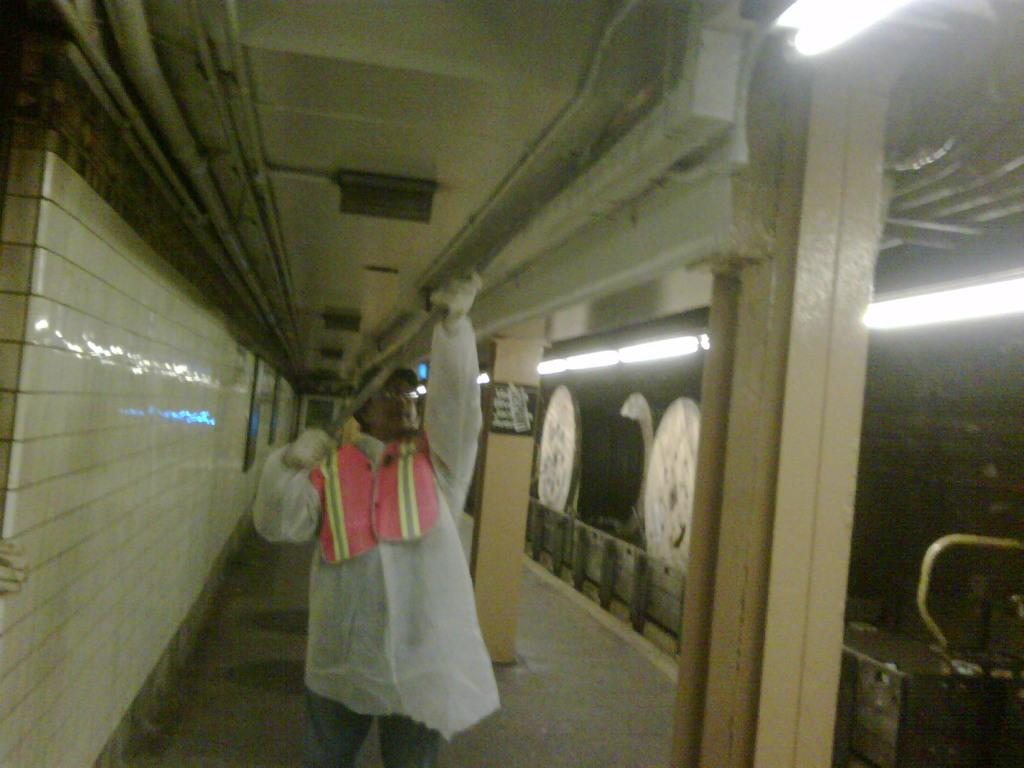What is the person in the image wearing? The person in the image is wearing a white dress. What can be seen on the right side of the image? There are lights on the right side of the image. What is on the left side of the image? There is a wall on the left side of the image. What type of print is visible on the wall in the image? There is no print visible on the wall in the image; it is a plain wall. 